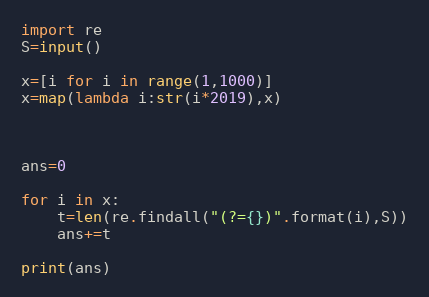<code> <loc_0><loc_0><loc_500><loc_500><_Python_>import re
S=input()

x=[i for i in range(1,1000)]
x=map(lambda i:str(i*2019),x)



ans=0

for i in x:
    t=len(re.findall("(?={})".format(i),S))
    ans+=t

print(ans)
</code> 